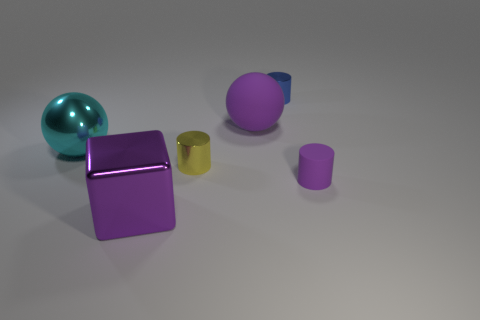Add 1 big matte cubes. How many objects exist? 7 Subtract all cyan spheres. How many spheres are left? 1 Subtract all metal cylinders. How many cylinders are left? 1 Subtract 1 purple cylinders. How many objects are left? 5 Subtract all blocks. How many objects are left? 5 Subtract 2 cylinders. How many cylinders are left? 1 Subtract all yellow balls. Subtract all cyan cylinders. How many balls are left? 2 Subtract all cyan blocks. How many yellow spheres are left? 0 Subtract all brown things. Subtract all small blue cylinders. How many objects are left? 5 Add 3 rubber balls. How many rubber balls are left? 4 